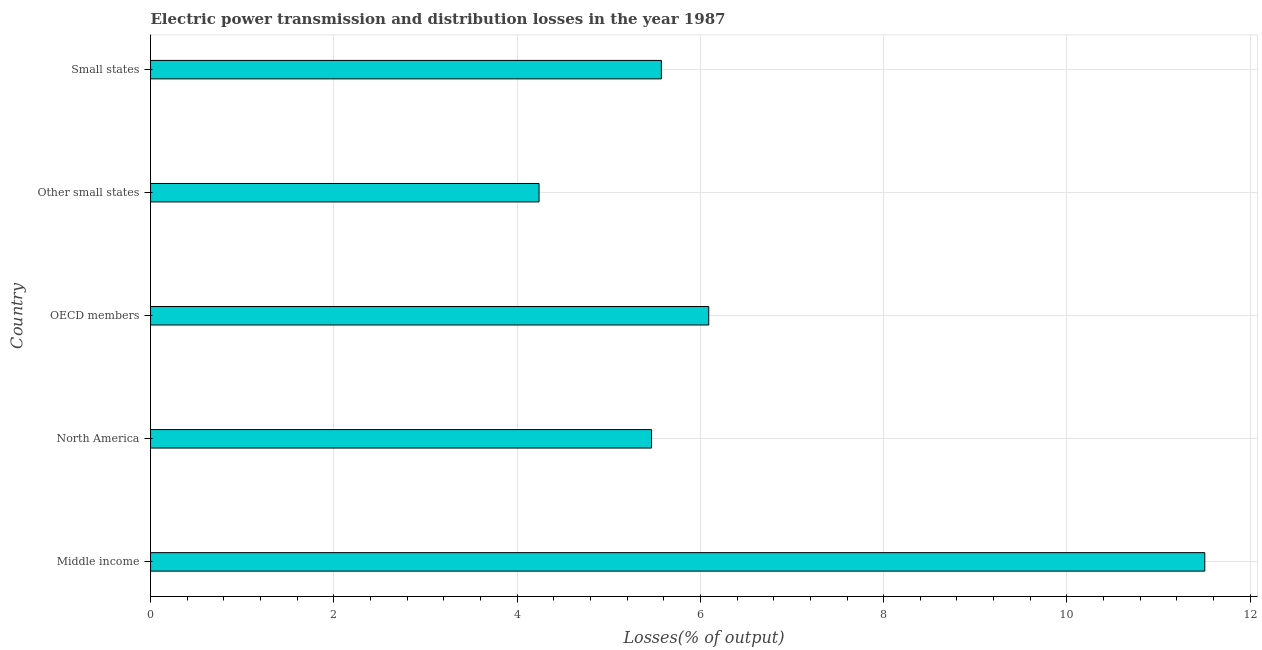What is the title of the graph?
Provide a short and direct response. Electric power transmission and distribution losses in the year 1987. What is the label or title of the X-axis?
Ensure brevity in your answer.  Losses(% of output). What is the label or title of the Y-axis?
Give a very brief answer. Country. What is the electric power transmission and distribution losses in OECD members?
Provide a short and direct response. 6.09. Across all countries, what is the maximum electric power transmission and distribution losses?
Your answer should be very brief. 11.5. Across all countries, what is the minimum electric power transmission and distribution losses?
Keep it short and to the point. 4.24. In which country was the electric power transmission and distribution losses maximum?
Provide a short and direct response. Middle income. In which country was the electric power transmission and distribution losses minimum?
Your answer should be very brief. Other small states. What is the sum of the electric power transmission and distribution losses?
Make the answer very short. 32.88. What is the difference between the electric power transmission and distribution losses in Middle income and OECD members?
Your response must be concise. 5.41. What is the average electric power transmission and distribution losses per country?
Offer a very short reply. 6.58. What is the median electric power transmission and distribution losses?
Keep it short and to the point. 5.57. In how many countries, is the electric power transmission and distribution losses greater than 8 %?
Offer a very short reply. 1. Is the difference between the electric power transmission and distribution losses in Middle income and North America greater than the difference between any two countries?
Make the answer very short. No. What is the difference between the highest and the second highest electric power transmission and distribution losses?
Ensure brevity in your answer.  5.41. What is the difference between the highest and the lowest electric power transmission and distribution losses?
Provide a short and direct response. 7.26. Are the values on the major ticks of X-axis written in scientific E-notation?
Your answer should be compact. No. What is the Losses(% of output) in Middle income?
Offer a very short reply. 11.5. What is the Losses(% of output) of North America?
Keep it short and to the point. 5.47. What is the Losses(% of output) in OECD members?
Your answer should be compact. 6.09. What is the Losses(% of output) in Other small states?
Your answer should be very brief. 4.24. What is the Losses(% of output) of Small states?
Provide a succinct answer. 5.57. What is the difference between the Losses(% of output) in Middle income and North America?
Ensure brevity in your answer.  6.04. What is the difference between the Losses(% of output) in Middle income and OECD members?
Your response must be concise. 5.41. What is the difference between the Losses(% of output) in Middle income and Other small states?
Keep it short and to the point. 7.26. What is the difference between the Losses(% of output) in Middle income and Small states?
Your response must be concise. 5.93. What is the difference between the Losses(% of output) in North America and OECD members?
Offer a terse response. -0.62. What is the difference between the Losses(% of output) in North America and Other small states?
Offer a very short reply. 1.23. What is the difference between the Losses(% of output) in North America and Small states?
Your answer should be compact. -0.11. What is the difference between the Losses(% of output) in OECD members and Other small states?
Your response must be concise. 1.85. What is the difference between the Losses(% of output) in OECD members and Small states?
Offer a terse response. 0.52. What is the difference between the Losses(% of output) in Other small states and Small states?
Provide a short and direct response. -1.33. What is the ratio of the Losses(% of output) in Middle income to that in North America?
Offer a very short reply. 2.1. What is the ratio of the Losses(% of output) in Middle income to that in OECD members?
Offer a terse response. 1.89. What is the ratio of the Losses(% of output) in Middle income to that in Other small states?
Your answer should be very brief. 2.71. What is the ratio of the Losses(% of output) in Middle income to that in Small states?
Your response must be concise. 2.06. What is the ratio of the Losses(% of output) in North America to that in OECD members?
Ensure brevity in your answer.  0.9. What is the ratio of the Losses(% of output) in North America to that in Other small states?
Provide a short and direct response. 1.29. What is the ratio of the Losses(% of output) in North America to that in Small states?
Ensure brevity in your answer.  0.98. What is the ratio of the Losses(% of output) in OECD members to that in Other small states?
Offer a terse response. 1.44. What is the ratio of the Losses(% of output) in OECD members to that in Small states?
Make the answer very short. 1.09. What is the ratio of the Losses(% of output) in Other small states to that in Small states?
Your response must be concise. 0.76. 